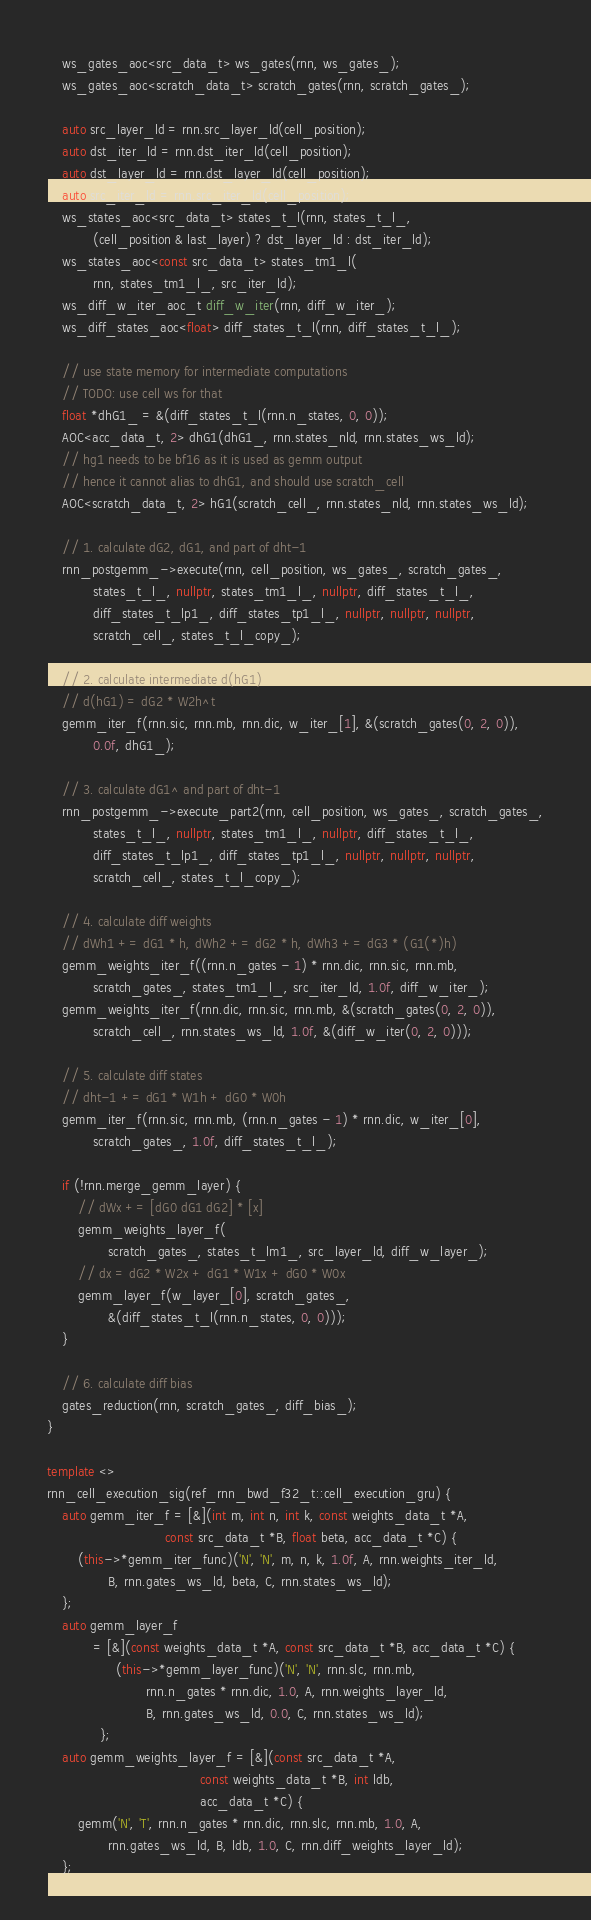<code> <loc_0><loc_0><loc_500><loc_500><_C++_>    ws_gates_aoc<src_data_t> ws_gates(rnn, ws_gates_);
    ws_gates_aoc<scratch_data_t> scratch_gates(rnn, scratch_gates_);

    auto src_layer_ld = rnn.src_layer_ld(cell_position);
    auto dst_iter_ld = rnn.dst_iter_ld(cell_position);
    auto dst_layer_ld = rnn.dst_layer_ld(cell_position);
    auto src_iter_ld = rnn.src_iter_ld(cell_position);
    ws_states_aoc<src_data_t> states_t_l(rnn, states_t_l_,
            (cell_position & last_layer) ? dst_layer_ld : dst_iter_ld);
    ws_states_aoc<const src_data_t> states_tm1_l(
            rnn, states_tm1_l_, src_iter_ld);
    ws_diff_w_iter_aoc_t diff_w_iter(rnn, diff_w_iter_);
    ws_diff_states_aoc<float> diff_states_t_l(rnn, diff_states_t_l_);

    // use state memory for intermediate computations
    // TODO: use cell ws for that
    float *dhG1_ = &(diff_states_t_l(rnn.n_states, 0, 0));
    AOC<acc_data_t, 2> dhG1(dhG1_, rnn.states_nld, rnn.states_ws_ld);
    // hg1 needs to be bf16 as it is used as gemm output
    // hence it cannot alias to dhG1, and should use scratch_cell
    AOC<scratch_data_t, 2> hG1(scratch_cell_, rnn.states_nld, rnn.states_ws_ld);

    // 1. calculate dG2, dG1, and part of dht-1
    rnn_postgemm_->execute(rnn, cell_position, ws_gates_, scratch_gates_,
            states_t_l_, nullptr, states_tm1_l_, nullptr, diff_states_t_l_,
            diff_states_t_lp1_, diff_states_tp1_l_, nullptr, nullptr, nullptr,
            scratch_cell_, states_t_l_copy_);

    // 2. calculate intermediate d(hG1)
    // d(hG1) = dG2 * W2h^t
    gemm_iter_f(rnn.sic, rnn.mb, rnn.dic, w_iter_[1], &(scratch_gates(0, 2, 0)),
            0.0f, dhG1_);

    // 3. calculate dG1^ and part of dht-1
    rnn_postgemm_->execute_part2(rnn, cell_position, ws_gates_, scratch_gates_,
            states_t_l_, nullptr, states_tm1_l_, nullptr, diff_states_t_l_,
            diff_states_t_lp1_, diff_states_tp1_l_, nullptr, nullptr, nullptr,
            scratch_cell_, states_t_l_copy_);

    // 4. calculate diff weights
    // dWh1 += dG1 * h, dWh2 += dG2 * h, dWh3 += dG3 * (G1(*)h)
    gemm_weights_iter_f((rnn.n_gates - 1) * rnn.dic, rnn.sic, rnn.mb,
            scratch_gates_, states_tm1_l_, src_iter_ld, 1.0f, diff_w_iter_);
    gemm_weights_iter_f(rnn.dic, rnn.sic, rnn.mb, &(scratch_gates(0, 2, 0)),
            scratch_cell_, rnn.states_ws_ld, 1.0f, &(diff_w_iter(0, 2, 0)));

    // 5. calculate diff states
    // dht-1 += dG1 * W1h + dG0 * W0h
    gemm_iter_f(rnn.sic, rnn.mb, (rnn.n_gates - 1) * rnn.dic, w_iter_[0],
            scratch_gates_, 1.0f, diff_states_t_l_);

    if (!rnn.merge_gemm_layer) {
        // dWx += [dG0 dG1 dG2] * [x]
        gemm_weights_layer_f(
                scratch_gates_, states_t_lm1_, src_layer_ld, diff_w_layer_);
        // dx = dG2 * W2x + dG1 * W1x + dG0 * W0x
        gemm_layer_f(w_layer_[0], scratch_gates_,
                &(diff_states_t_l(rnn.n_states, 0, 0)));
    }

    // 6. calculate diff bias
    gates_reduction(rnn, scratch_gates_, diff_bias_);
}

template <>
rnn_cell_execution_sig(ref_rnn_bwd_f32_t::cell_execution_gru) {
    auto gemm_iter_f = [&](int m, int n, int k, const weights_data_t *A,
                               const src_data_t *B, float beta, acc_data_t *C) {
        (this->*gemm_iter_func)('N', 'N', m, n, k, 1.0f, A, rnn.weights_iter_ld,
                B, rnn.gates_ws_ld, beta, C, rnn.states_ws_ld);
    };
    auto gemm_layer_f
            = [&](const weights_data_t *A, const src_data_t *B, acc_data_t *C) {
                  (this->*gemm_layer_func)('N', 'N', rnn.slc, rnn.mb,
                          rnn.n_gates * rnn.dic, 1.0, A, rnn.weights_layer_ld,
                          B, rnn.gates_ws_ld, 0.0, C, rnn.states_ws_ld);
              };
    auto gemm_weights_layer_f = [&](const src_data_t *A,
                                        const weights_data_t *B, int ldb,
                                        acc_data_t *C) {
        gemm('N', 'T', rnn.n_gates * rnn.dic, rnn.slc, rnn.mb, 1.0, A,
                rnn.gates_ws_ld, B, ldb, 1.0, C, rnn.diff_weights_layer_ld);
    };</code> 